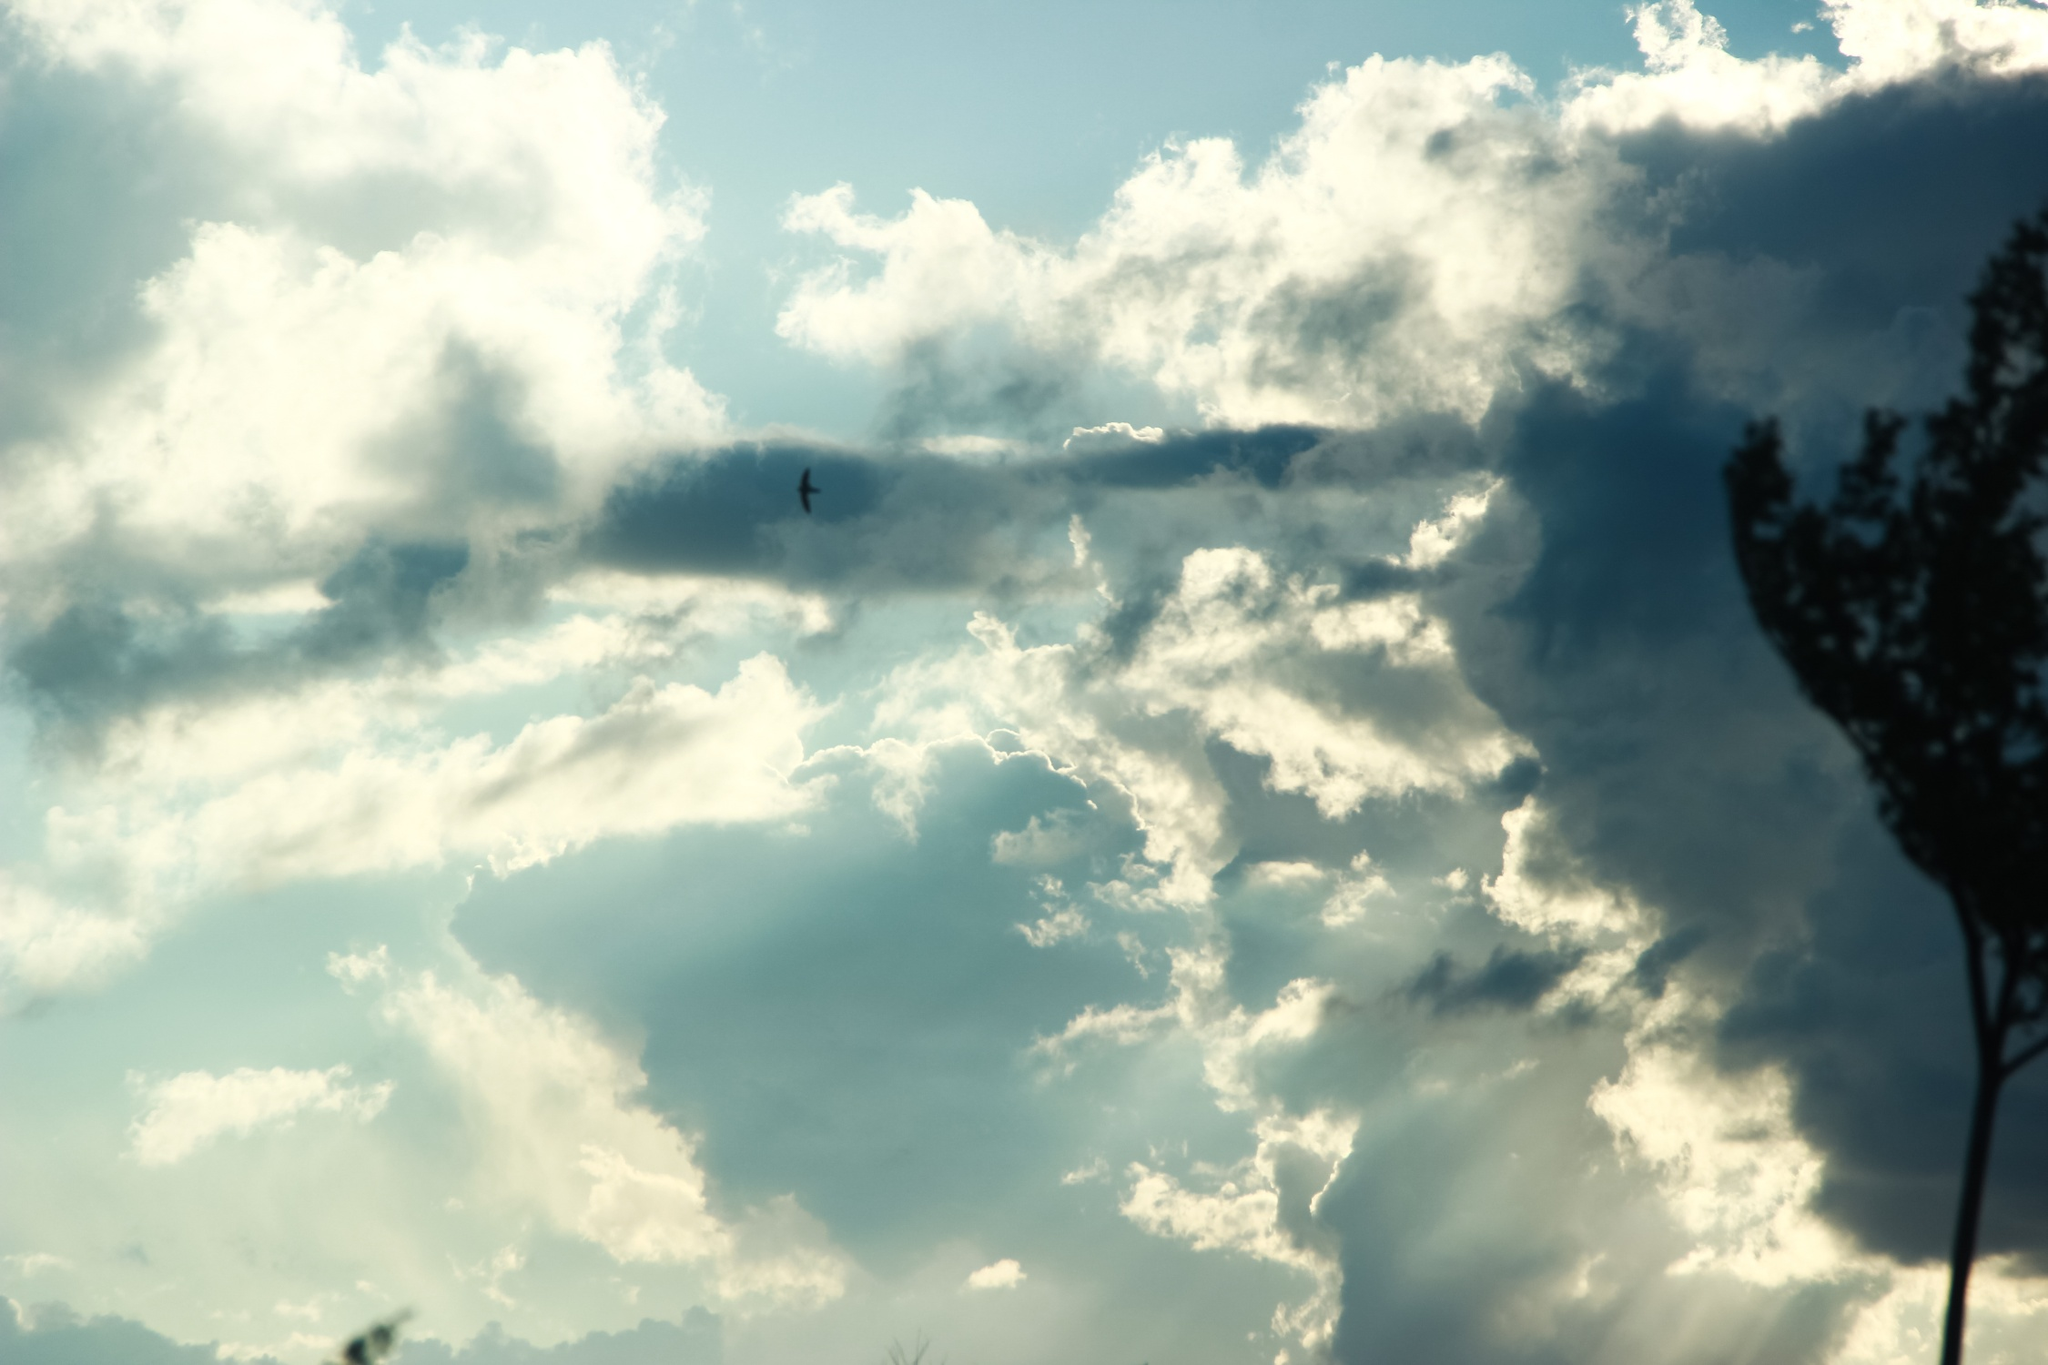What emotions does this photo evoke? The photo evokes a profound sense of serenity and peacefulness. The vast blue sky, dotted with billowing clouds, alongside the solitary silhouette of the tree, creates a calming and contemplative mood. The bird in flight adds a layer of freedom and hope, suggesting a harmonious connection with nature. 